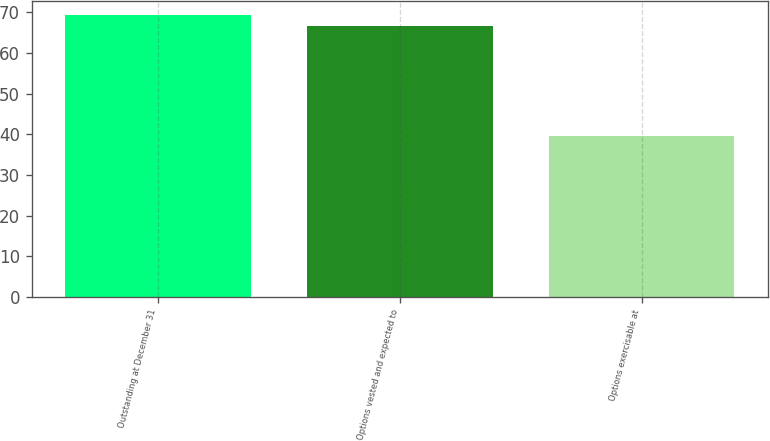Convert chart to OTSL. <chart><loc_0><loc_0><loc_500><loc_500><bar_chart><fcel>Outstanding at December 31<fcel>Options vested and expected to<fcel>Options exercisable at<nl><fcel>69.27<fcel>66.57<fcel>39.68<nl></chart> 